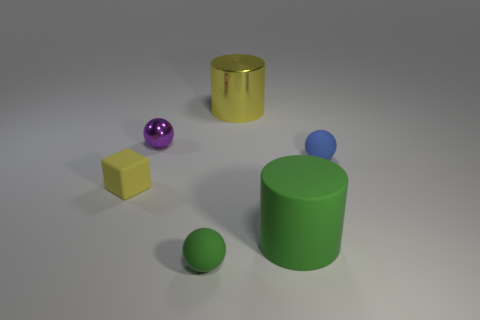Subtract all purple blocks. Subtract all gray balls. How many blocks are left? 1 Add 1 matte blocks. How many objects exist? 7 Subtract all cylinders. How many objects are left? 4 Subtract 1 green balls. How many objects are left? 5 Subtract all brown metallic blocks. Subtract all purple things. How many objects are left? 5 Add 6 big yellow cylinders. How many big yellow cylinders are left? 7 Add 6 tiny purple metal blocks. How many tiny purple metal blocks exist? 6 